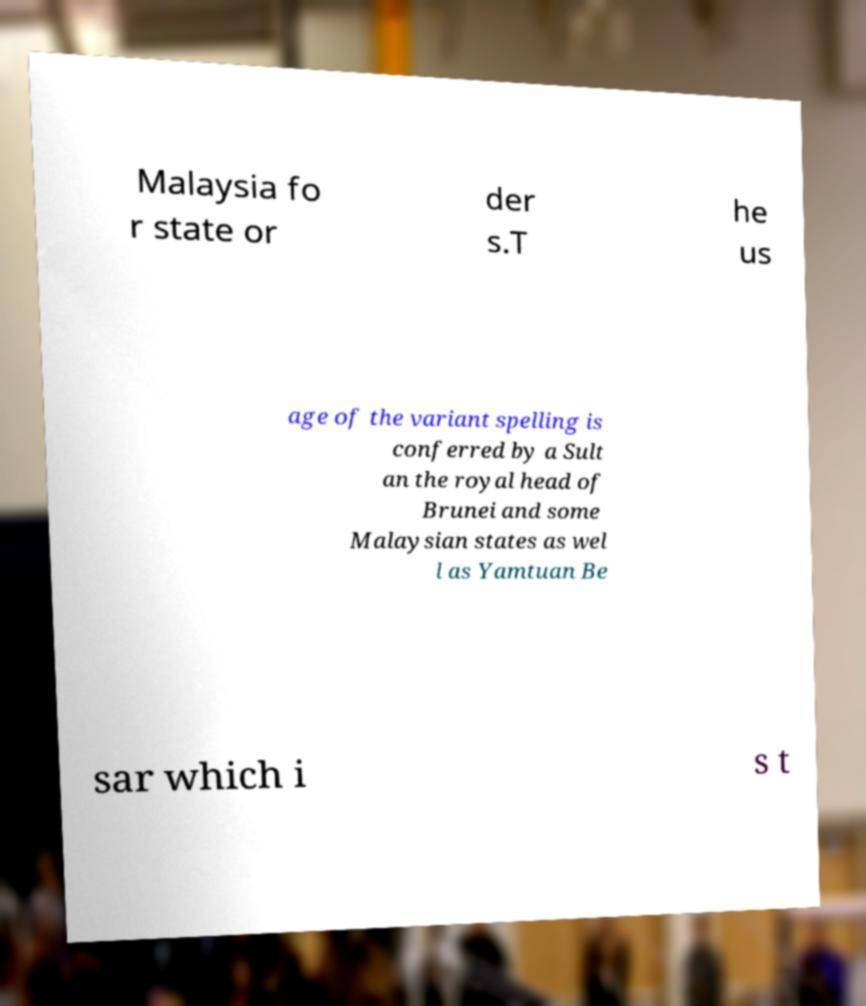Could you extract and type out the text from this image? Malaysia fo r state or der s.T he us age of the variant spelling is conferred by a Sult an the royal head of Brunei and some Malaysian states as wel l as Yamtuan Be sar which i s t 